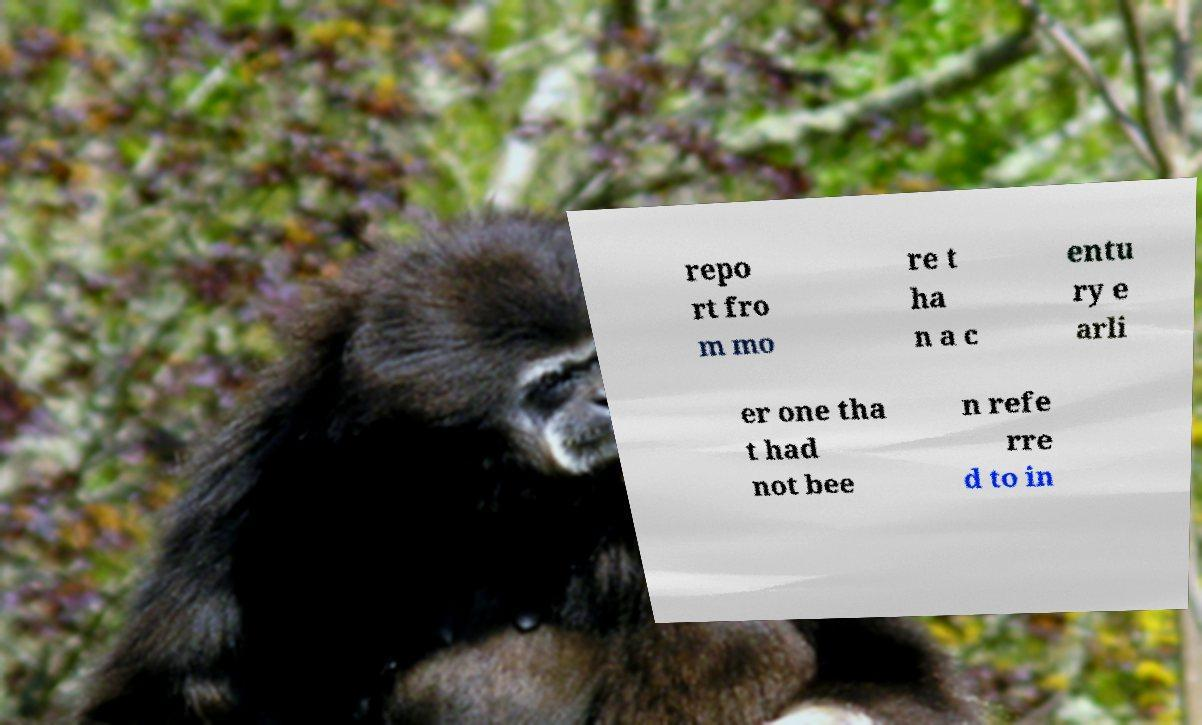I need the written content from this picture converted into text. Can you do that? repo rt fro m mo re t ha n a c entu ry e arli er one tha t had not bee n refe rre d to in 